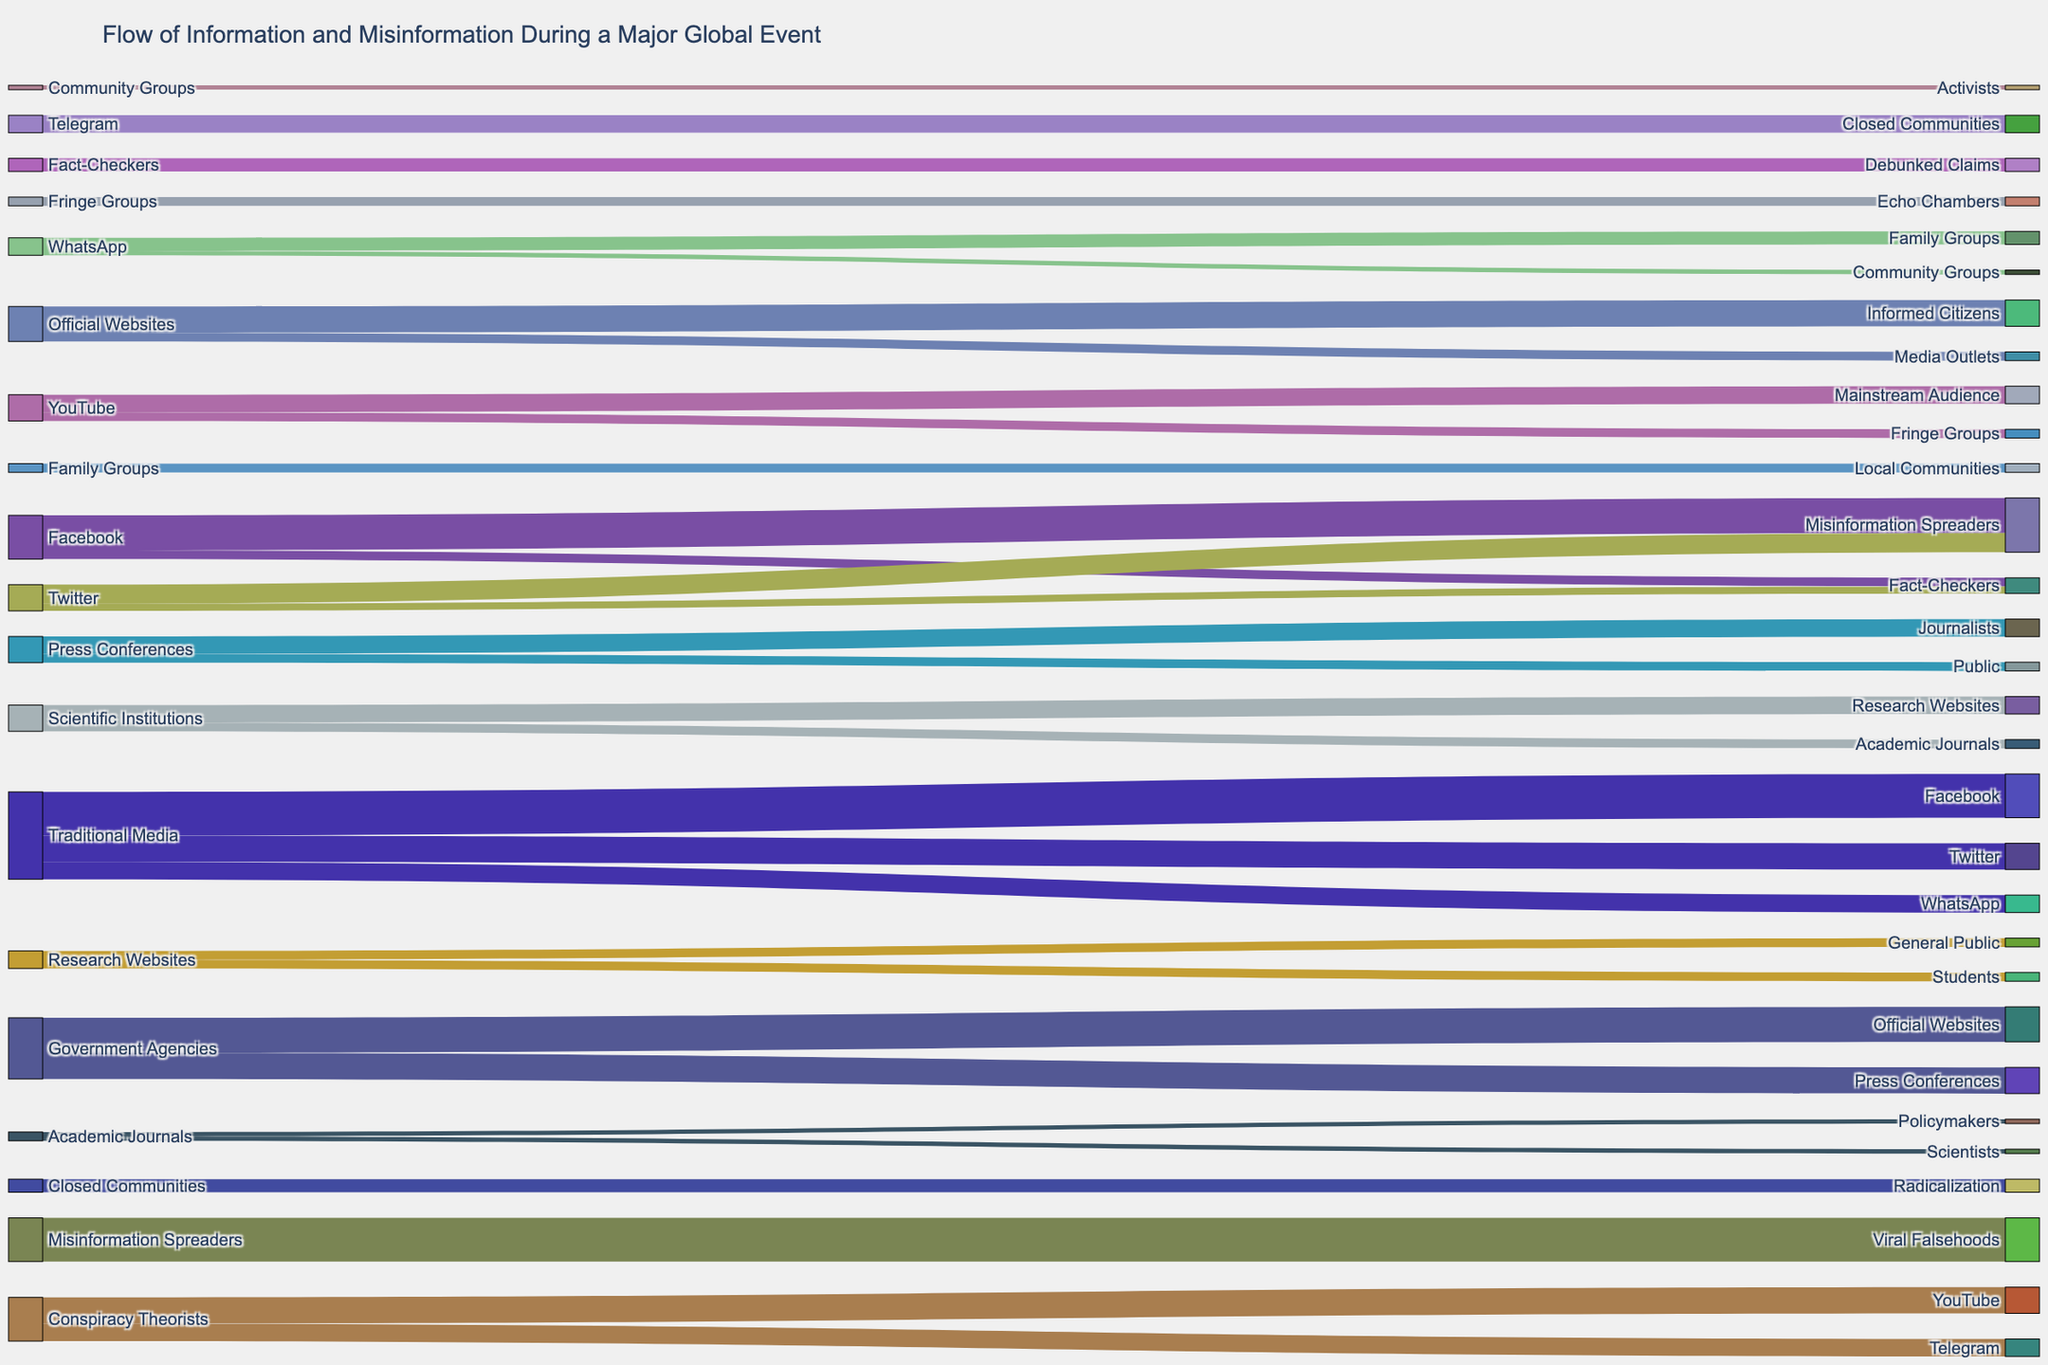What's the title of the figure? The title is located at the top of the figure and summarizes the content of the diagram.
Answer: Flow of Information and Misinformation During a Major Global Event Which source contributed the most to Facebook? Look at the connections going into Facebook and identify the one with the highest value. Traditional Media contributed 5,000,000.
Answer: Traditional Media How much misinformation is spread from Facebook to misinformation spreaders? Find the connection between Facebook and misinformation spreaders and note the value.
Answer: 4,000,000 What is the total value of information going into Twitter? Sum the values of all connections leading to Twitter: Traditional Media to Twitter (3,000,000).
Answer: 3,000,000 Which platform receives the most misinformation from conspiracy theorists? Compare the values of connections from conspiracy theorists to different platforms. YouTube (3,000,000) is more than Telegram (2,000,000).
Answer: YouTube What is the combined value of Facebook and Twitter contributions to misinformation spreaders? Sum the values of Facebook to misinformation spreaders (4,000,000) and Twitter to misinformation spreaders (2,200,000).
Answer: 6,200,000 Which target group has the highest value coming from YouTube? Look at the connections going out of YouTube and identify the highest value, which is to the mainstream audience (2,000,000).
Answer: Mainstream Audience How does the value from official websites to media outlets compare to the value from official websites to informed citizens? Compare the two values: media outlets (1,000,000) and informed citizens (3,000,000).
Answer: Informed citizens have a higher value What's the total value of information coming from government agencies? Sum values from government agencies to all targets: official websites (4,000,000) + press conferences (3,000,000) = 7,000,000.
Answer: 7,000,000 How much information do press conferences contribute to the public? Look at the connection value from press conferences to the public.
Answer: 1,000,000 